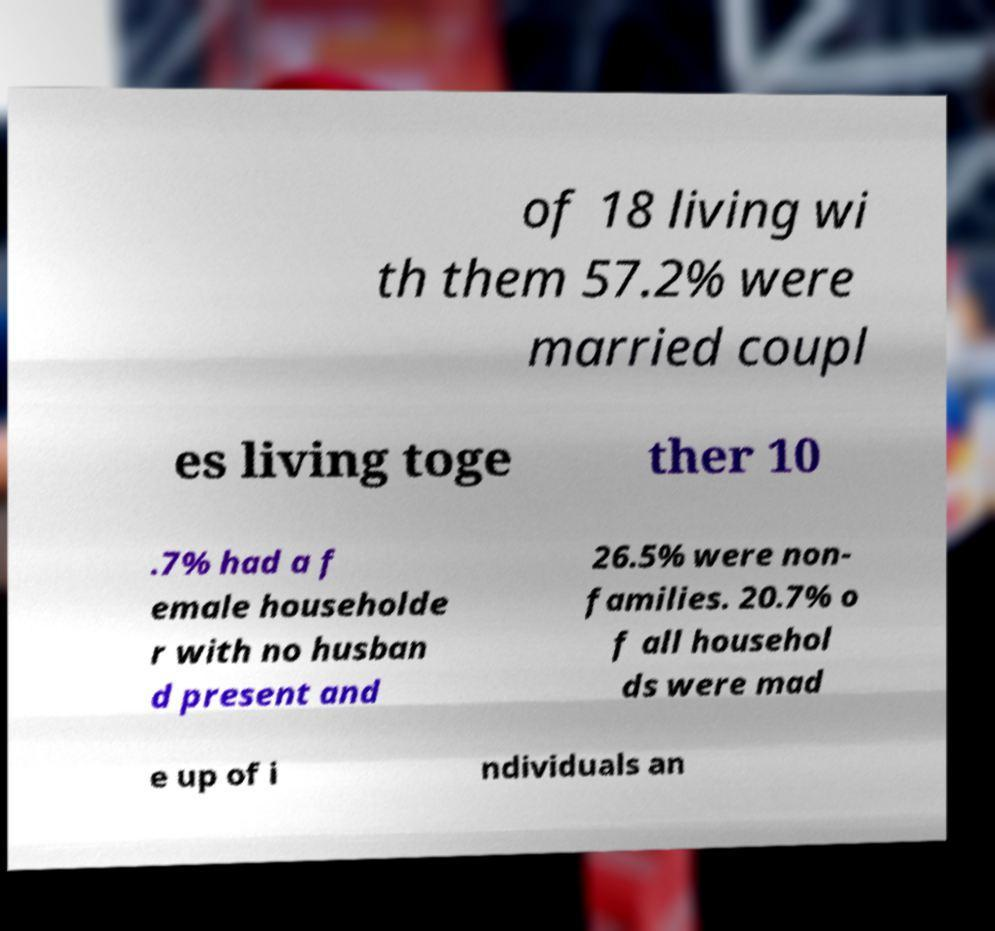Please identify and transcribe the text found in this image. of 18 living wi th them 57.2% were married coupl es living toge ther 10 .7% had a f emale householde r with no husban d present and 26.5% were non- families. 20.7% o f all househol ds were mad e up of i ndividuals an 